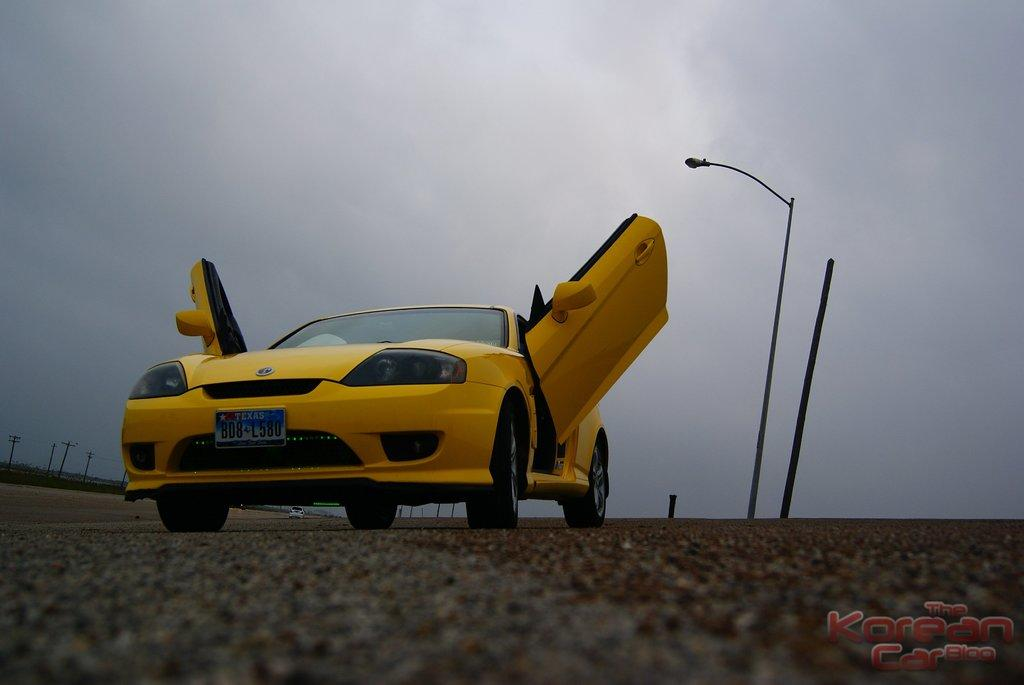What is located on the ground in the image? There is a car on the ground in the image. What structures are present in the image besides the car? There are light poles in the image. What is visible at the top of the image? The sky is visible at the top of the image. Where can text be found in the image? There is some text written in the right corner of the image. What type of butter is being used to grease the turkey in the image? There is no butter or turkey present in the image; it features a car on the ground, light poles, the sky, and text in the right corner. 